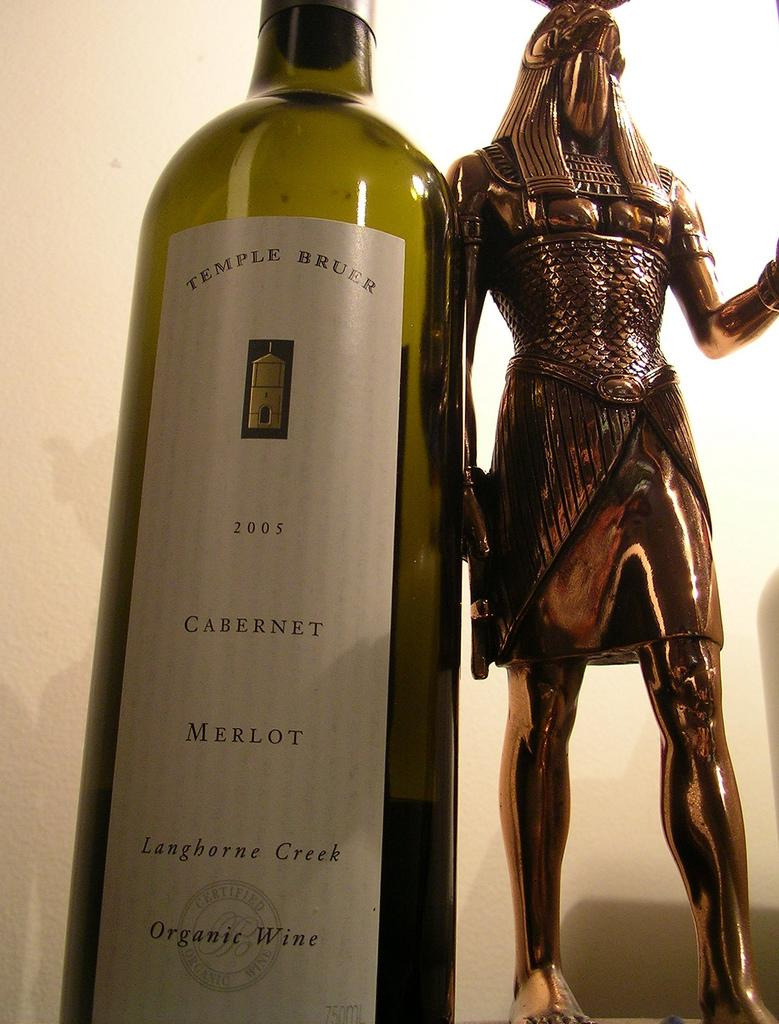<image>
Give a short and clear explanation of the subsequent image. The bottle of wine is from the company Temple Bruer 